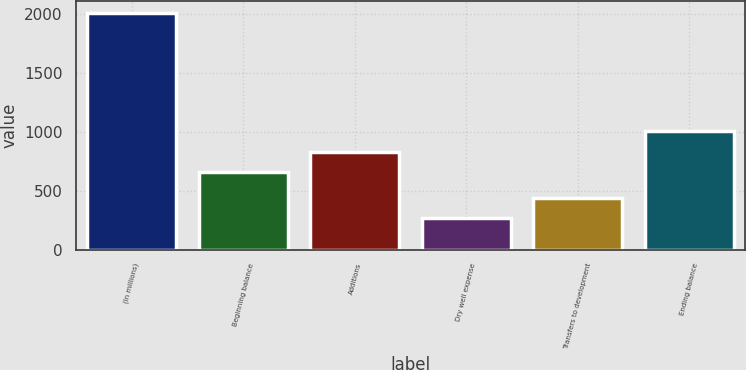Convert chart to OTSL. <chart><loc_0><loc_0><loc_500><loc_500><bar_chart><fcel>(In millions)<fcel>Beginning balance<fcel>Additions<fcel>Dry well expense<fcel>Transfers to development<fcel>Ending balance<nl><fcel>2011<fcel>657<fcel>831.3<fcel>268<fcel>442.3<fcel>1005.6<nl></chart> 